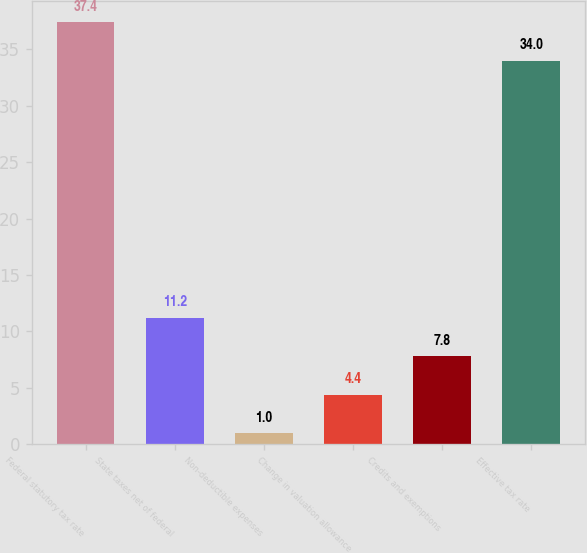Convert chart. <chart><loc_0><loc_0><loc_500><loc_500><bar_chart><fcel>Federal statutory tax rate<fcel>State taxes net of federal<fcel>Non-deductible expenses<fcel>Change in valuation allowance<fcel>Credits and exemptions<fcel>Effective tax rate<nl><fcel>37.4<fcel>11.2<fcel>1<fcel>4.4<fcel>7.8<fcel>34<nl></chart> 